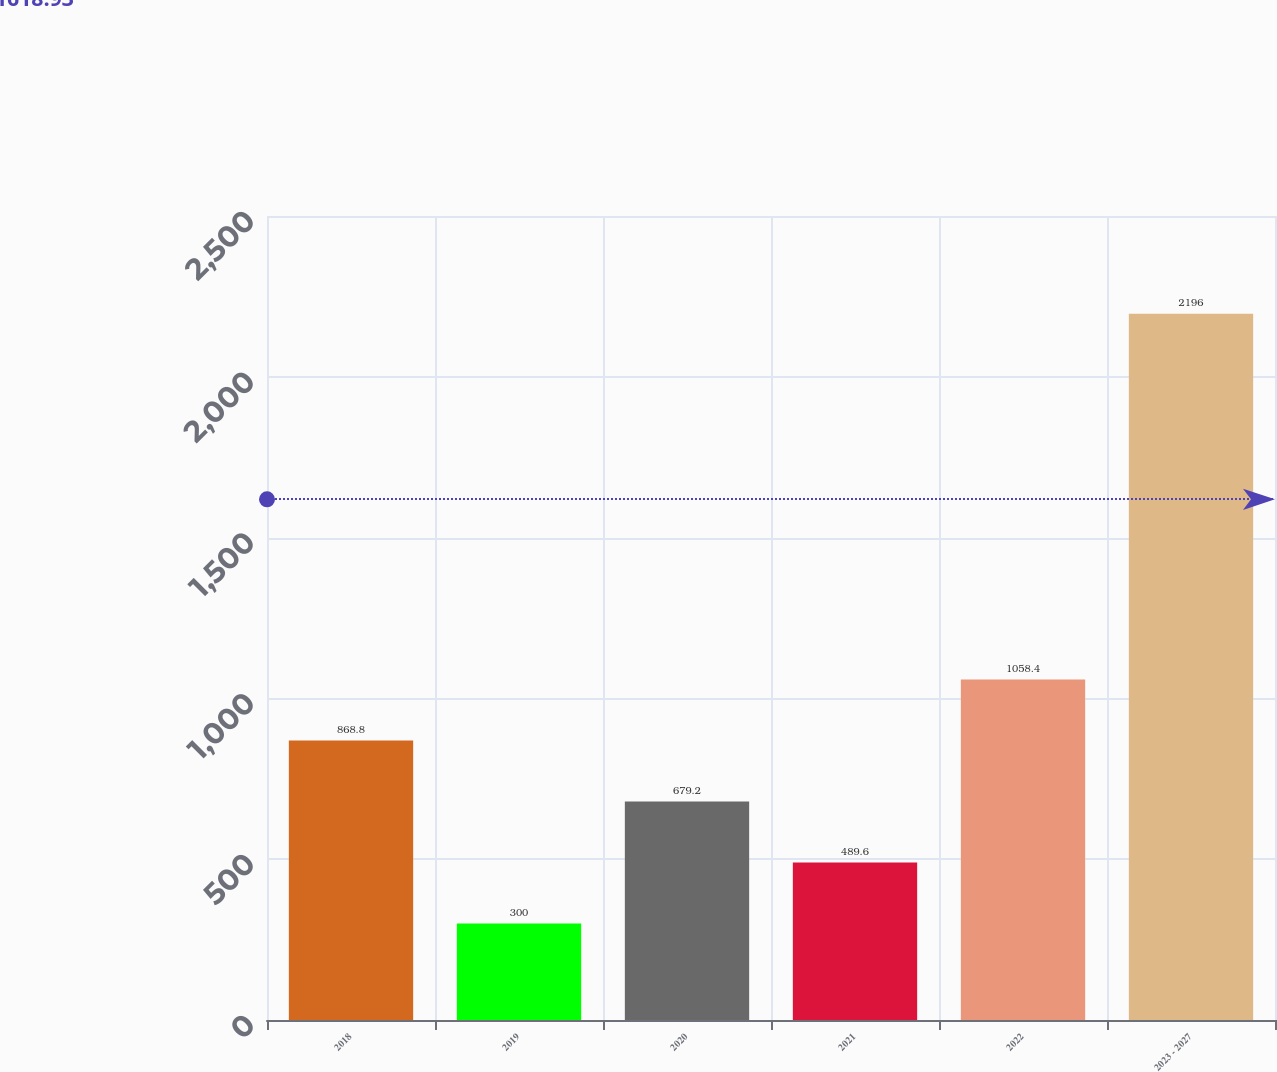Convert chart. <chart><loc_0><loc_0><loc_500><loc_500><bar_chart><fcel>2018<fcel>2019<fcel>2020<fcel>2021<fcel>2022<fcel>2023 - 2027<nl><fcel>868.8<fcel>300<fcel>679.2<fcel>489.6<fcel>1058.4<fcel>2196<nl></chart> 